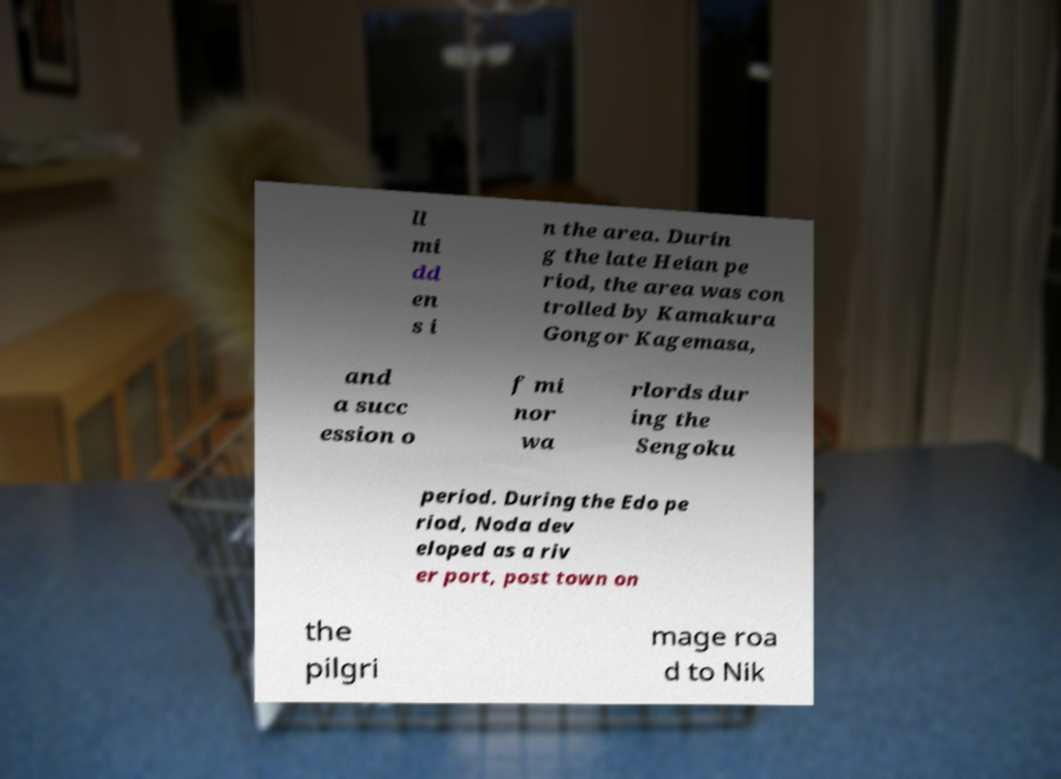Please identify and transcribe the text found in this image. ll mi dd en s i n the area. Durin g the late Heian pe riod, the area was con trolled by Kamakura Gongor Kagemasa, and a succ ession o f mi nor wa rlords dur ing the Sengoku period. During the Edo pe riod, Noda dev eloped as a riv er port, post town on the pilgri mage roa d to Nik 